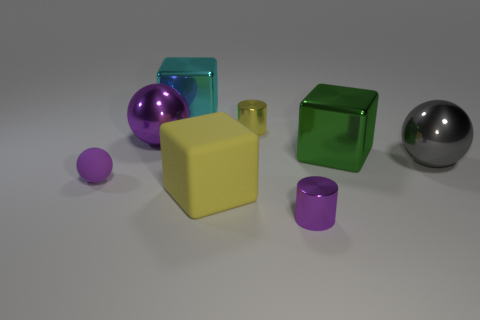Add 1 gray shiny cylinders. How many objects exist? 9 Subtract all metal blocks. How many blocks are left? 1 Subtract 2 cubes. How many cubes are left? 1 Subtract all yellow cylinders. How many cylinders are left? 1 Subtract 0 blue spheres. How many objects are left? 8 Subtract all cylinders. How many objects are left? 6 Subtract all blue spheres. Subtract all gray blocks. How many spheres are left? 3 Subtract all red cylinders. How many cyan blocks are left? 1 Subtract all brown rubber spheres. Subtract all yellow metal objects. How many objects are left? 7 Add 1 tiny balls. How many tiny balls are left? 2 